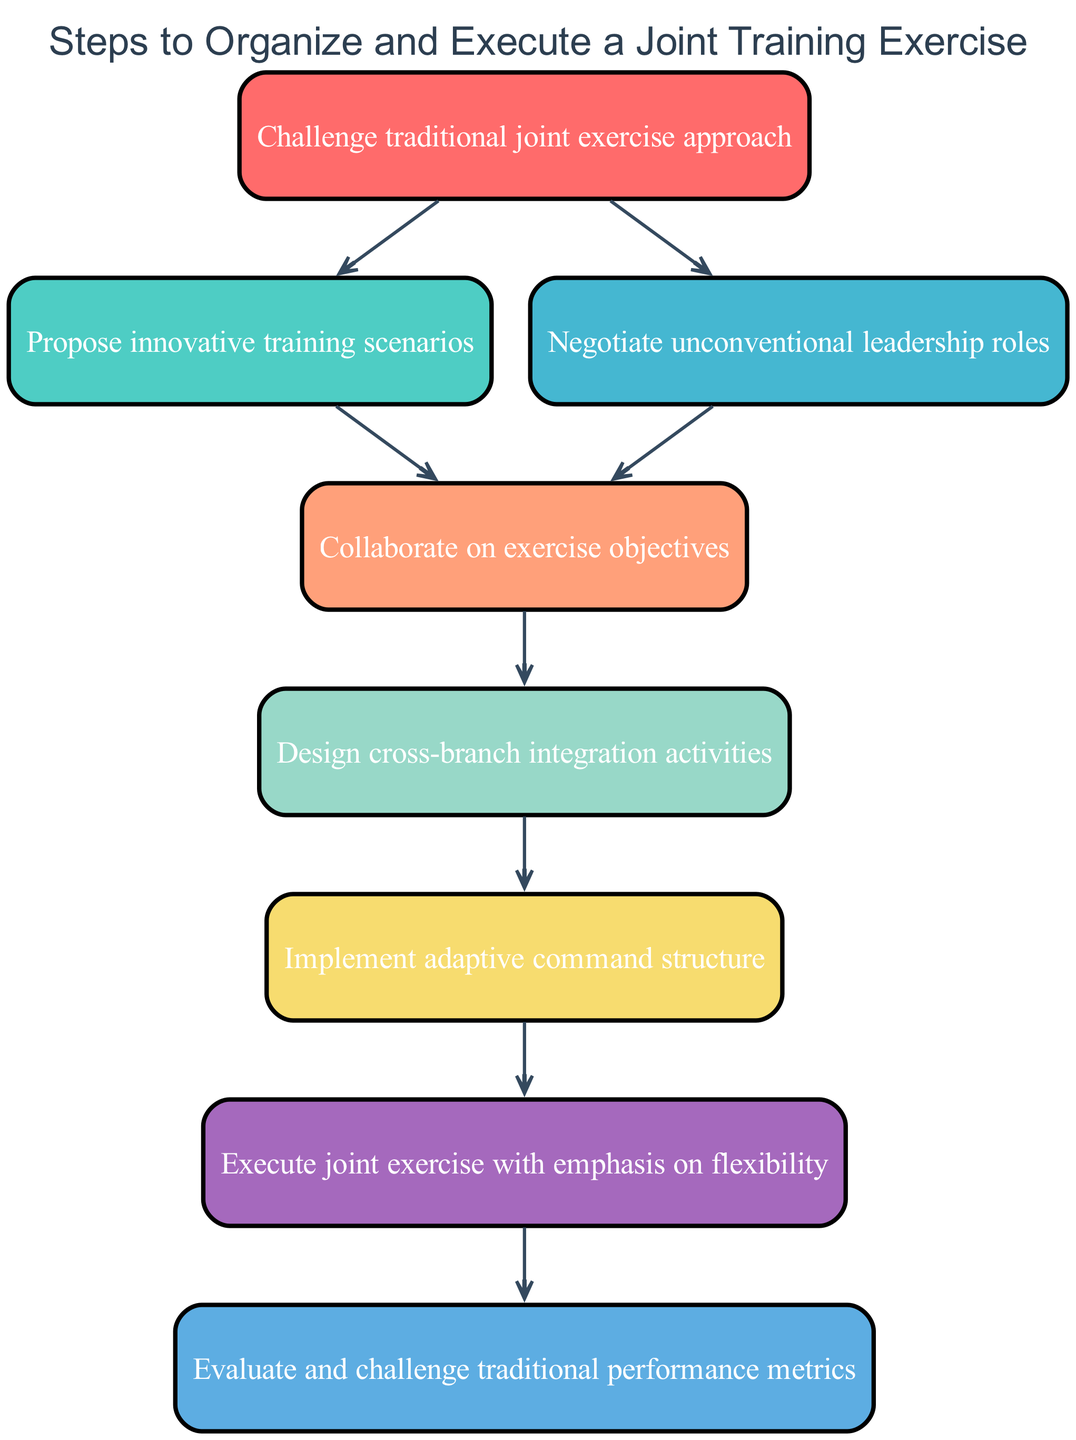What is the first step in the exercise organization process? The first step listed in the diagram is "Challenge traditional joint exercise approach," as it is the initial node before any others.
Answer: Challenge traditional joint exercise approach How many nodes are there in total in the diagram? Counting all listed elements in the flow chart, there are 8 nodes representing distinct steps in the process.
Answer: 8 What action is taken after proposing innovative training scenarios? According to the flow, the next action after proposing innovative training scenarios is "Collaborate on exercise objectives," thus indicating a linear progression in the process.
Answer: Collaborate on exercise objectives Which node emphasizes flexibility during execution? The diagram indicates that "Execute joint exercise with emphasis on flexibility" is the specific step that focuses on this attribute during execution.
Answer: Execute joint exercise with emphasis on flexibility What is the outcome of evaluating traditional performance metrics? The last action in the flow chart is "Evaluate and challenge traditional performance metrics," suggesting an assessment phase that likely leads to future improvements or new standards.
Answer: Evaluate and challenge traditional performance metrics Is there any repetition of concepts in the diagram? While the steps are distinct, the themes of innovation and evaluation appear multiple times, showing a focus on challenging norms throughout the process.
Answer: Yes Which step follows after implementing an adaptive command structure? The next step after implementing an adaptive command structure is "Execute joint exercise with emphasis on flexibility," highlighting practical application following structural adjustments.
Answer: Execute joint exercise with emphasis on flexibility What type of leadership negotiations are included in the process? The diagram includes "Negotiate unconventional leadership roles," indicating a focus on atypical leadership arrangements as part of the exercise organization.
Answer: Negotiate unconventional leadership roles 